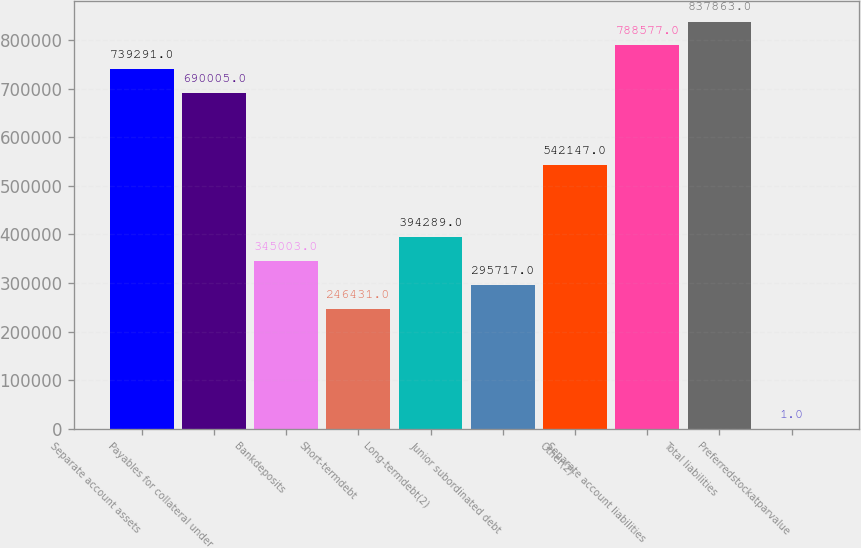Convert chart to OTSL. <chart><loc_0><loc_0><loc_500><loc_500><bar_chart><fcel>Separate account assets<fcel>Payables for collateral under<fcel>Bankdeposits<fcel>Short-termdebt<fcel>Long-termdebt(2)<fcel>Junior subordinated debt<fcel>Other(2)<fcel>Separate account liabilities<fcel>Total liabilities<fcel>Preferredstockatparvalue<nl><fcel>739291<fcel>690005<fcel>345003<fcel>246431<fcel>394289<fcel>295717<fcel>542147<fcel>788577<fcel>837863<fcel>1<nl></chart> 